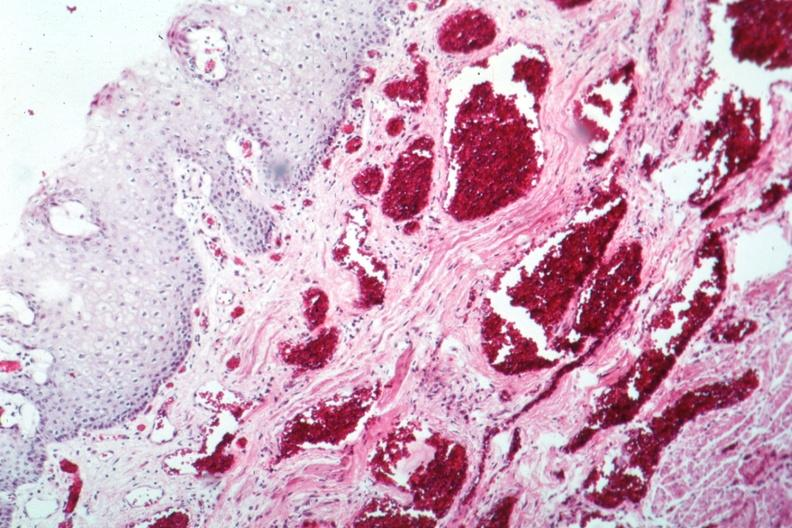s varices present?
Answer the question using a single word or phrase. Yes 